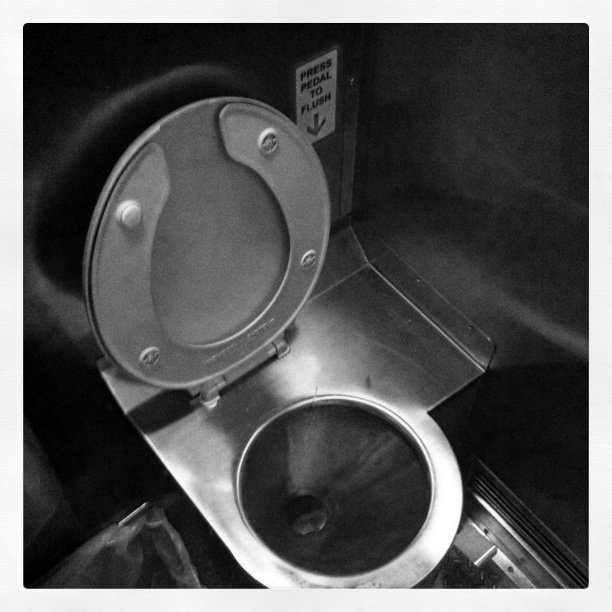Describe the objects in this image and their specific colors. I can see a toilet in white, gray, black, darkgray, and lightgray tones in this image. 